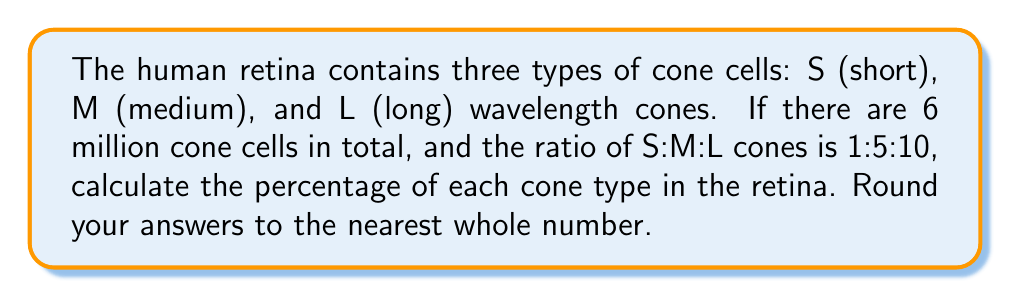What is the answer to this math problem? 1. First, let's determine the total parts in the ratio:
   $1 + 5 + 10 = 16$ parts

2. Calculate the number of each cone type:
   S cones: $\frac{1}{16} \times 6,000,000 = 375,000$
   M cones: $\frac{5}{16} \times 6,000,000 = 1,875,000$
   L cones: $\frac{10}{16} \times 6,000,000 = 3,750,000$

3. Calculate the percentage of each cone type:
   S cones: $\frac{375,000}{6,000,000} \times 100\% = 6.25\%$
   M cones: $\frac{1,875,000}{6,000,000} \times 100\% = 31.25\%$
   L cones: $\frac{3,750,000}{6,000,000} \times 100\% = 62.5\%$

4. Round to the nearest whole number:
   S cones: 6%
   M cones: 31%
   L cones: 63%
Answer: S: 6%, M: 31%, L: 63% 